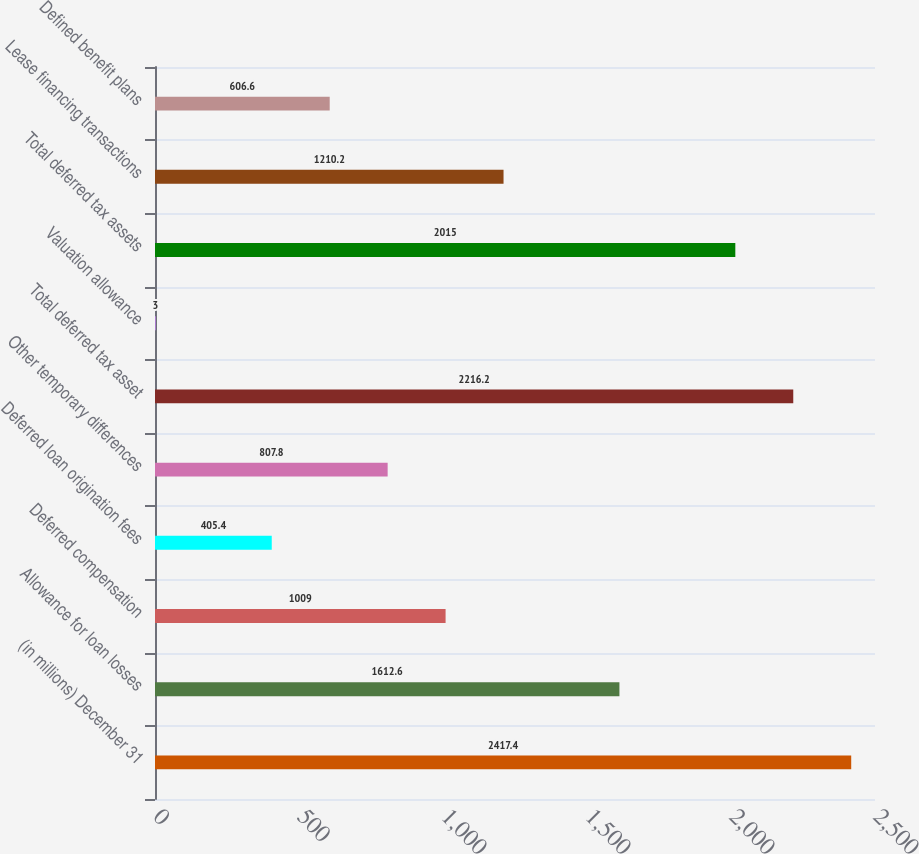Convert chart to OTSL. <chart><loc_0><loc_0><loc_500><loc_500><bar_chart><fcel>(in millions) December 31<fcel>Allowance for loan losses<fcel>Deferred compensation<fcel>Deferred loan origination fees<fcel>Other temporary differences<fcel>Total deferred tax asset<fcel>Valuation allowance<fcel>Total deferred tax assets<fcel>Lease financing transactions<fcel>Defined benefit plans<nl><fcel>2417.4<fcel>1612.6<fcel>1009<fcel>405.4<fcel>807.8<fcel>2216.2<fcel>3<fcel>2015<fcel>1210.2<fcel>606.6<nl></chart> 